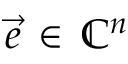<formula> <loc_0><loc_0><loc_500><loc_500>\vec { e } \, \in \, \mathbb { C } ^ { n }</formula> 